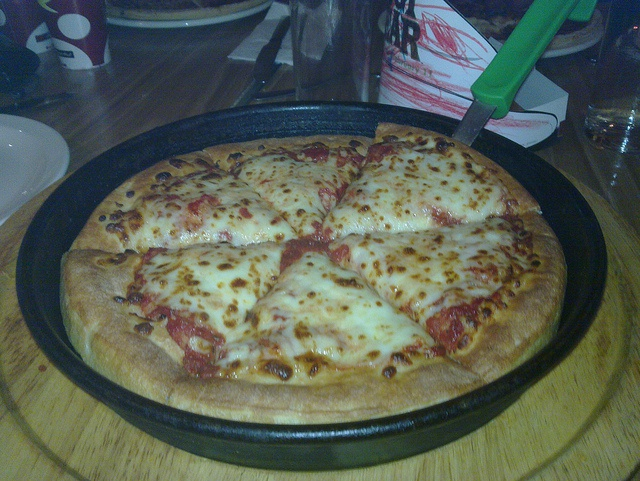Describe the objects in this image and their specific colors. I can see pizza in blue, gray, darkgray, and olive tones, dining table in blue, gray, black, darkgreen, and navy tones, cup in blue, navy, and black tones, knife in blue, teal, navy, darkgreen, and green tones, and cup in blue, black, navy, and gray tones in this image. 